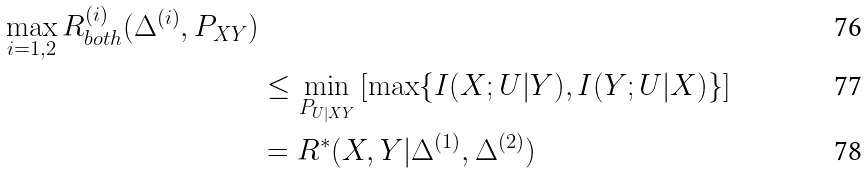Convert formula to latex. <formula><loc_0><loc_0><loc_500><loc_500>{ \max _ { i = 1 , 2 } R _ { b o t h } ^ { ( i ) } ( \Delta ^ { ( i ) } , P _ { X Y } ) } \\ & \leq \min _ { P _ { U | X Y } } \left [ \max \{ I ( X ; U | Y ) , I ( Y ; U | X ) \} \right ] \\ & = R ^ { * } ( X , Y | \Delta ^ { ( 1 ) } , \Delta ^ { ( 2 ) } )</formula> 